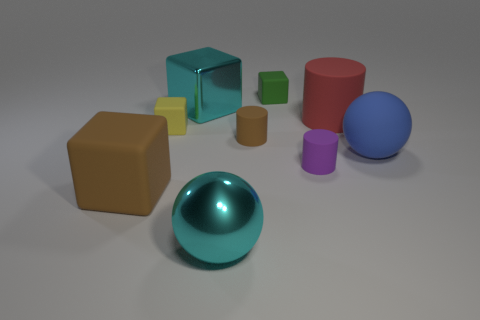Subtract all green cubes. How many cubes are left? 3 Subtract all purple blocks. Subtract all gray balls. How many blocks are left? 4 Add 1 tiny yellow cubes. How many objects exist? 10 Subtract all balls. How many objects are left? 7 Add 2 blue matte things. How many blue matte things exist? 3 Subtract 1 cyan blocks. How many objects are left? 8 Subtract all large blue matte cylinders. Subtract all cyan metal spheres. How many objects are left? 8 Add 4 big cyan spheres. How many big cyan spheres are left? 5 